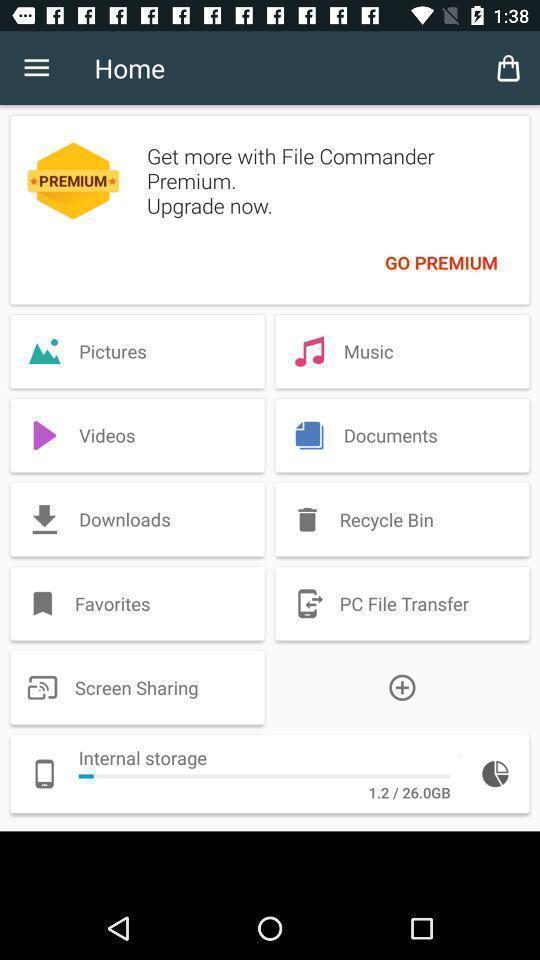Tell me what you see in this picture. Various tools in a home page. 